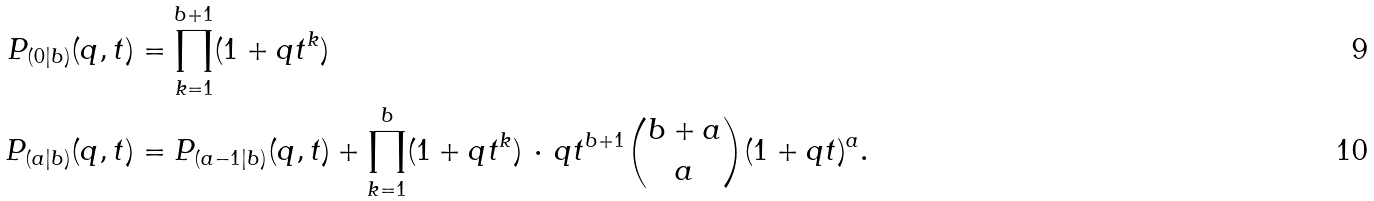<formula> <loc_0><loc_0><loc_500><loc_500>P _ { ( 0 | b ) } ( q , t ) & = \prod _ { k = 1 } ^ { b + 1 } ( 1 + q t ^ { k } ) \\ P _ { ( a | b ) } ( q , t ) & = P _ { ( a - 1 | b ) } ( q , t ) + \prod _ { k = 1 } ^ { b } ( 1 + q t ^ { k } ) \, \cdot \, q t ^ { b + 1 } { b + a \choose a } ( 1 + q t ) ^ { a } .</formula> 